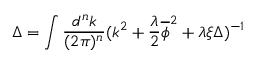Convert formula to latex. <formula><loc_0><loc_0><loc_500><loc_500>\Delta = \int \frac { d ^ { n } k } { ( 2 \pi ) ^ { n } } ( k ^ { 2 } + \frac { \lambda } { 2 } \overline { \phi } ^ { 2 } + \lambda \xi \Delta ) ^ { - 1 }</formula> 